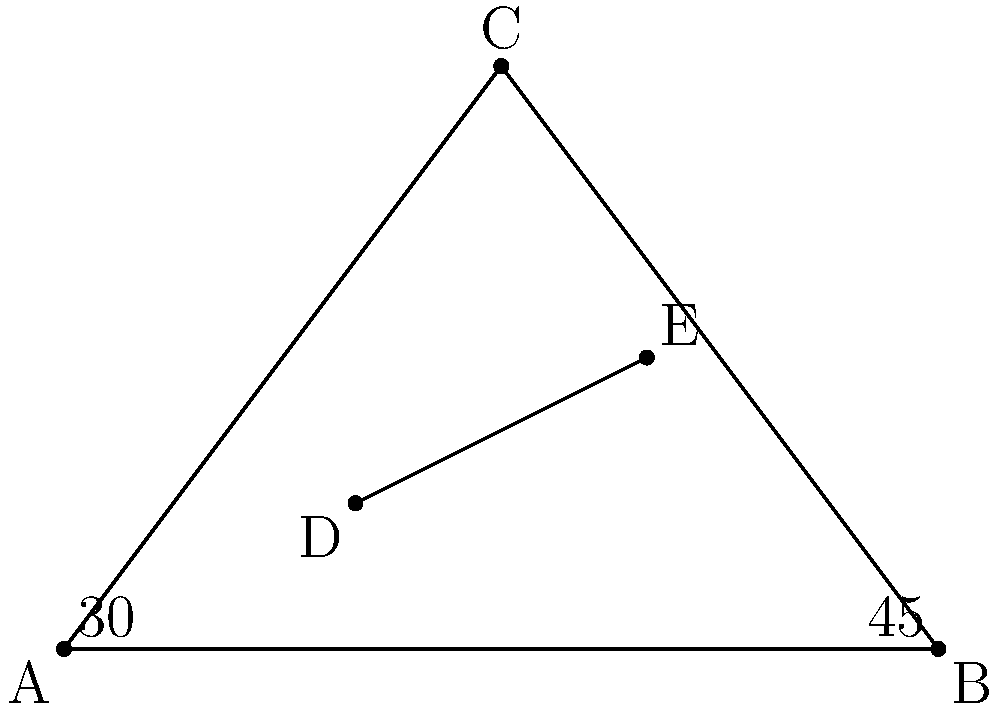During a complex chord, a banjo player's fingers form a triangle ABC on the fretboard, with angle A measuring $30°$ and angle B measuring $45°$. Two additional fingers placed at points D and E form a line segment DE parallel to BC. If AD:DB = 1:2, what is the measure of angle ADE? Let's approach this step-by-step:

1) First, we need to find angle C of the triangle ABC:
   $\angle C = 180° - (30° + 45°) = 105°$

2) In triangle ABC, DE is parallel to BC. This means that triangles ADE and ABC are similar.

3) The ratio AD:DB = 1:2 implies that AD is 1/3 of AB, and DE is 1/3 of BC.

4) In similar triangles, corresponding angles are equal. Therefore:
   $\angle ADE = \angle ABC = 45°$

5) We can also verify this using the angle sum property of triangles:
   $\angle DAE + \angle ADE + \angle AED = 180°$
   $30° + 45° + \angle AED = 180°$
   $\angle AED = 105°$

   This confirms that triangle ADE is indeed similar to triangle ABC.

Therefore, the measure of angle ADE is 45°.
Answer: $45°$ 